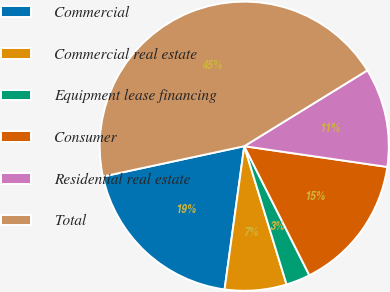Convert chart. <chart><loc_0><loc_0><loc_500><loc_500><pie_chart><fcel>Commercial<fcel>Commercial real estate<fcel>Equipment lease financing<fcel>Consumer<fcel>Residential real estate<fcel>Total<nl><fcel>19.46%<fcel>6.9%<fcel>2.71%<fcel>15.27%<fcel>11.08%<fcel>44.58%<nl></chart> 